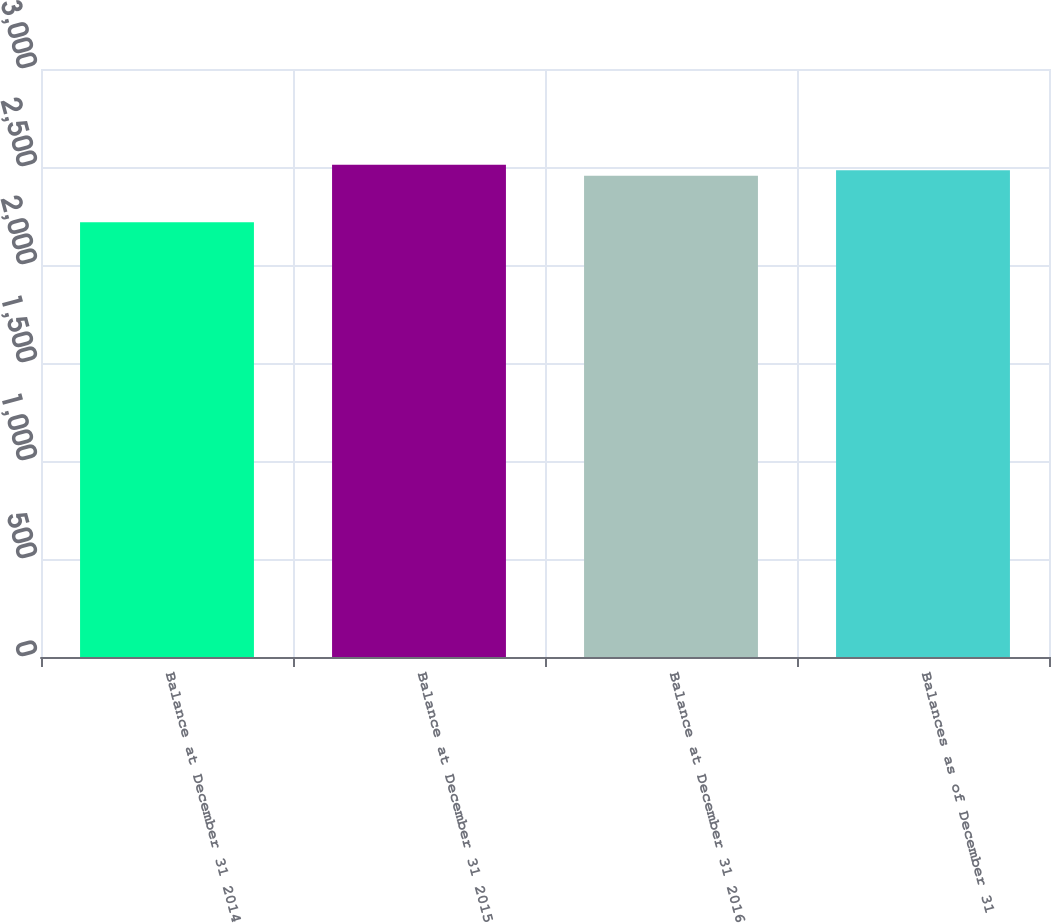Convert chart. <chart><loc_0><loc_0><loc_500><loc_500><bar_chart><fcel>Balance at December 31 2014<fcel>Balance at December 31 2015<fcel>Balance at December 31 2016<fcel>Balances as of December 31<nl><fcel>2217.6<fcel>2511.56<fcel>2455<fcel>2483.28<nl></chart> 